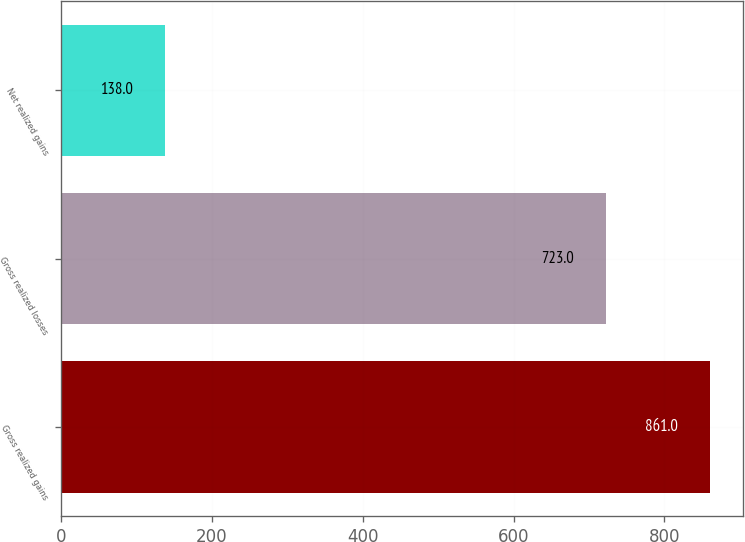Convert chart to OTSL. <chart><loc_0><loc_0><loc_500><loc_500><bar_chart><fcel>Gross realized gains<fcel>Gross realized losses<fcel>Net realized gains<nl><fcel>861<fcel>723<fcel>138<nl></chart> 